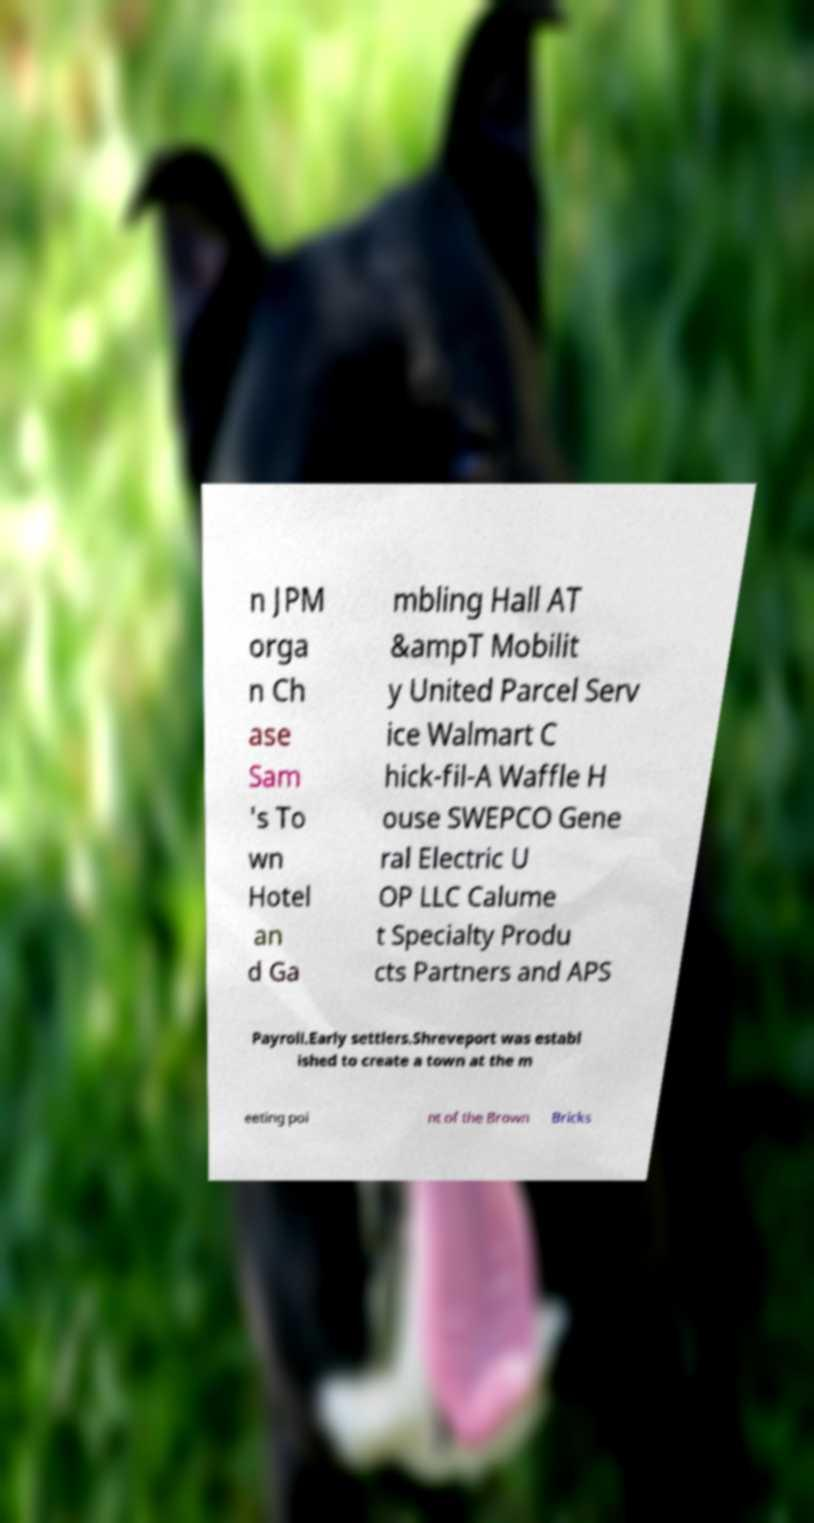What messages or text are displayed in this image? I need them in a readable, typed format. n JPM orga n Ch ase Sam 's To wn Hotel an d Ga mbling Hall AT &ampT Mobilit y United Parcel Serv ice Walmart C hick-fil-A Waffle H ouse SWEPCO Gene ral Electric U OP LLC Calume t Specialty Produ cts Partners and APS Payroll.Early settlers.Shreveport was establ ished to create a town at the m eeting poi nt of the Brown Bricks 